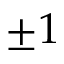Convert formula to latex. <formula><loc_0><loc_0><loc_500><loc_500>\pm 1</formula> 